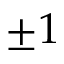Convert formula to latex. <formula><loc_0><loc_0><loc_500><loc_500>\pm 1</formula> 